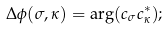<formula> <loc_0><loc_0><loc_500><loc_500>\Delta \phi ( \sigma , \kappa ) = \arg ( c _ { \sigma } c _ { \kappa } ^ { * } ) ;</formula> 